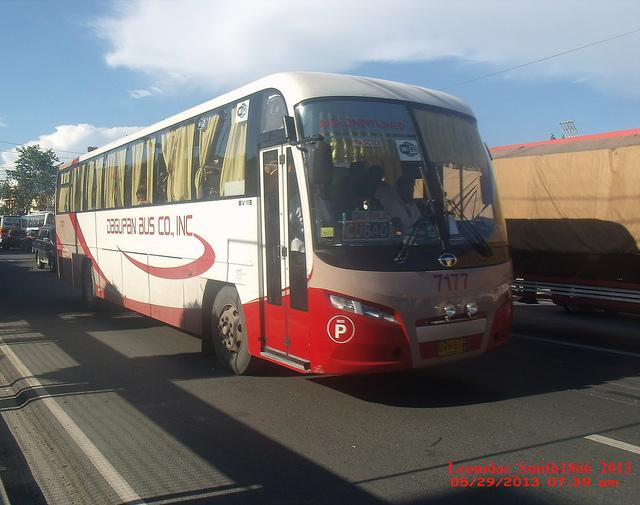Which street lane or lanes is the bus traveling in? both 